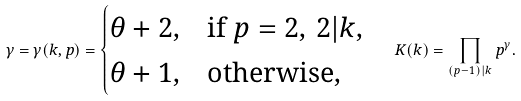<formula> <loc_0><loc_0><loc_500><loc_500>\gamma = \gamma ( k , p ) = \begin{cases} \theta + 2 , & \text {if } p = 2 , \, 2 | k , \\ \theta + 1 , & \text {otherwise,} \end{cases} \quad K ( k ) = \prod _ { ( p - 1 ) | k } p ^ { \gamma } .</formula> 